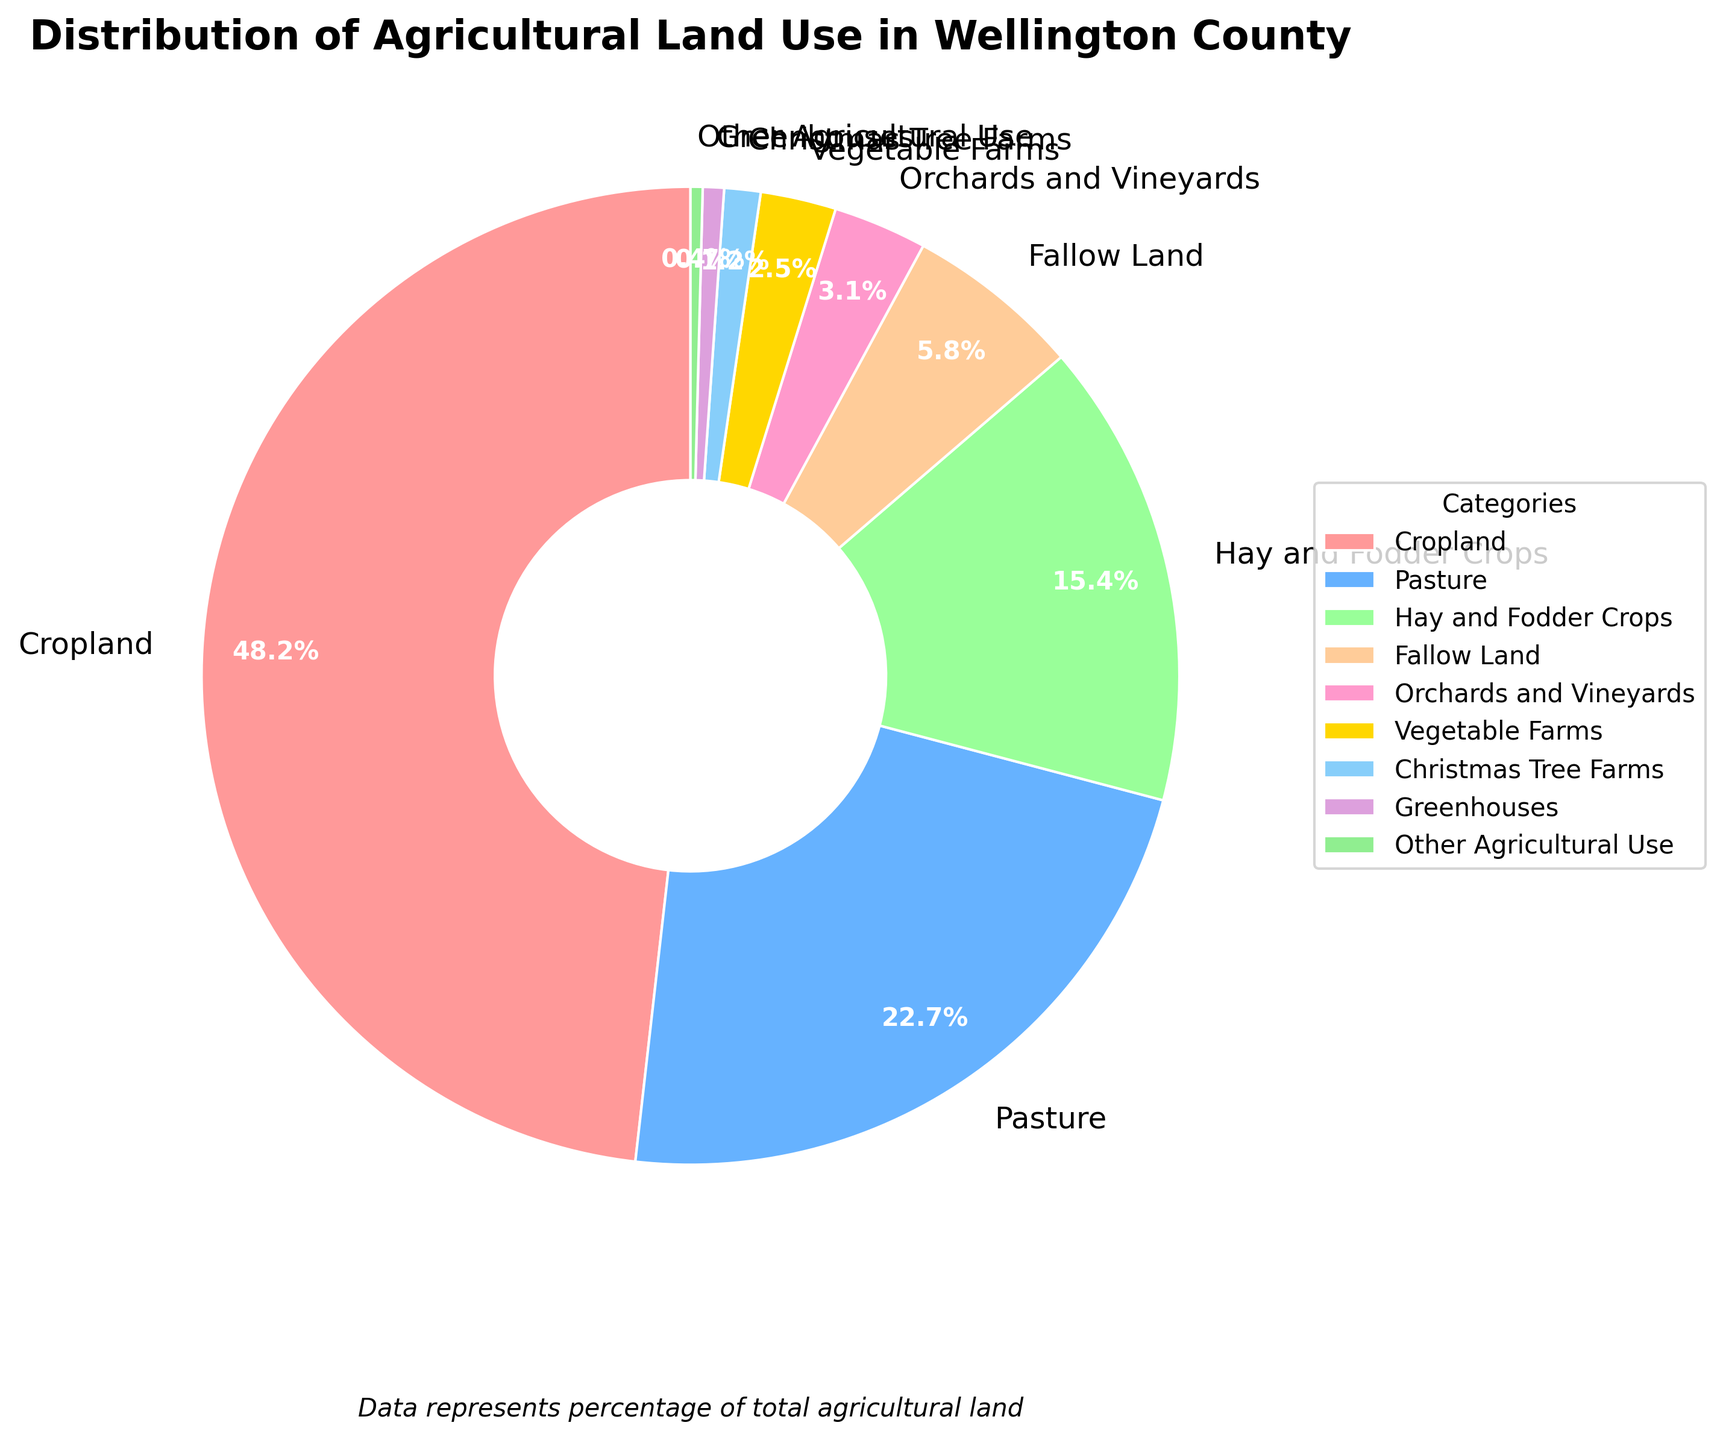What is the most common type of agricultural land use in Wellington County? Cropland has the highest percentage at 48.2%, making it the most common type of agricultural land use.
Answer: Cropland Which category has the smallest percentage of agricultural land use? From the chart, "Other Agricultural Use" has the smallest percentage at 0.4%.
Answer: Other Agricultural Use How much more percentage of land is used for Hay and Fodder Crops compared to Vegetable Farms? The percentage for Hay and Fodder Crops is 15.4%, and for Vegetable Farms, it is 2.5%. The difference is 15.4% - 2.5% = 12.9%.
Answer: 12.9% What is the combined percentage of land used for Orchards and Vineyards, and Christmas Tree Farms? The percentage for Orchards and Vineyards is 3.1%, and for Christmas Tree Farms, it is 1.2%. The combined percentage is 3.1% + 1.2% = 4.3%.
Answer: 4.3% How does the percentage of land used for Pasture compare to that of Fallow Land? The percentage for Pasture is 22.7%, while for Fallow Land it is 5.8%. Pasture has a higher percentage than Fallow Land.
Answer: Pasture has more What is the total percentage of land used for Greenhouses and Other Agricultural Use together? The percentage for Greenhouses is 0.7%, and for Other Agricultural Use it is 0.4%. The total percentage is 0.7% + 0.4% = 1.1%.
Answer: 1.1% Which categories have a total land use percentage greater than 60%? Cropland (48.2%), Pasture (22.7%), and Hay and Fodder Crops (15.4%) have a combined percentage of 48.2% + 22.7% + 15.4% = 86.3%, which is greater than 60%.
Answer: Cropland, Pasture, and Hay and Fodder Crops 